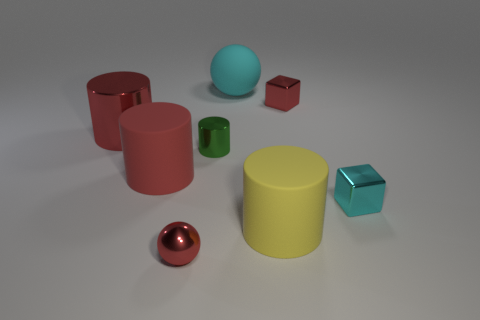Subtract all green cylinders. How many cylinders are left? 3 Subtract all brown cubes. How many red cylinders are left? 2 Subtract 3 cylinders. How many cylinders are left? 1 Subtract all red cylinders. How many cylinders are left? 2 Add 1 yellow matte cylinders. How many objects exist? 9 Add 1 tiny green things. How many tiny green things are left? 2 Add 5 shiny cubes. How many shiny cubes exist? 7 Subtract 0 brown cylinders. How many objects are left? 8 Subtract all blocks. How many objects are left? 6 Subtract all green cubes. Subtract all red balls. How many cubes are left? 2 